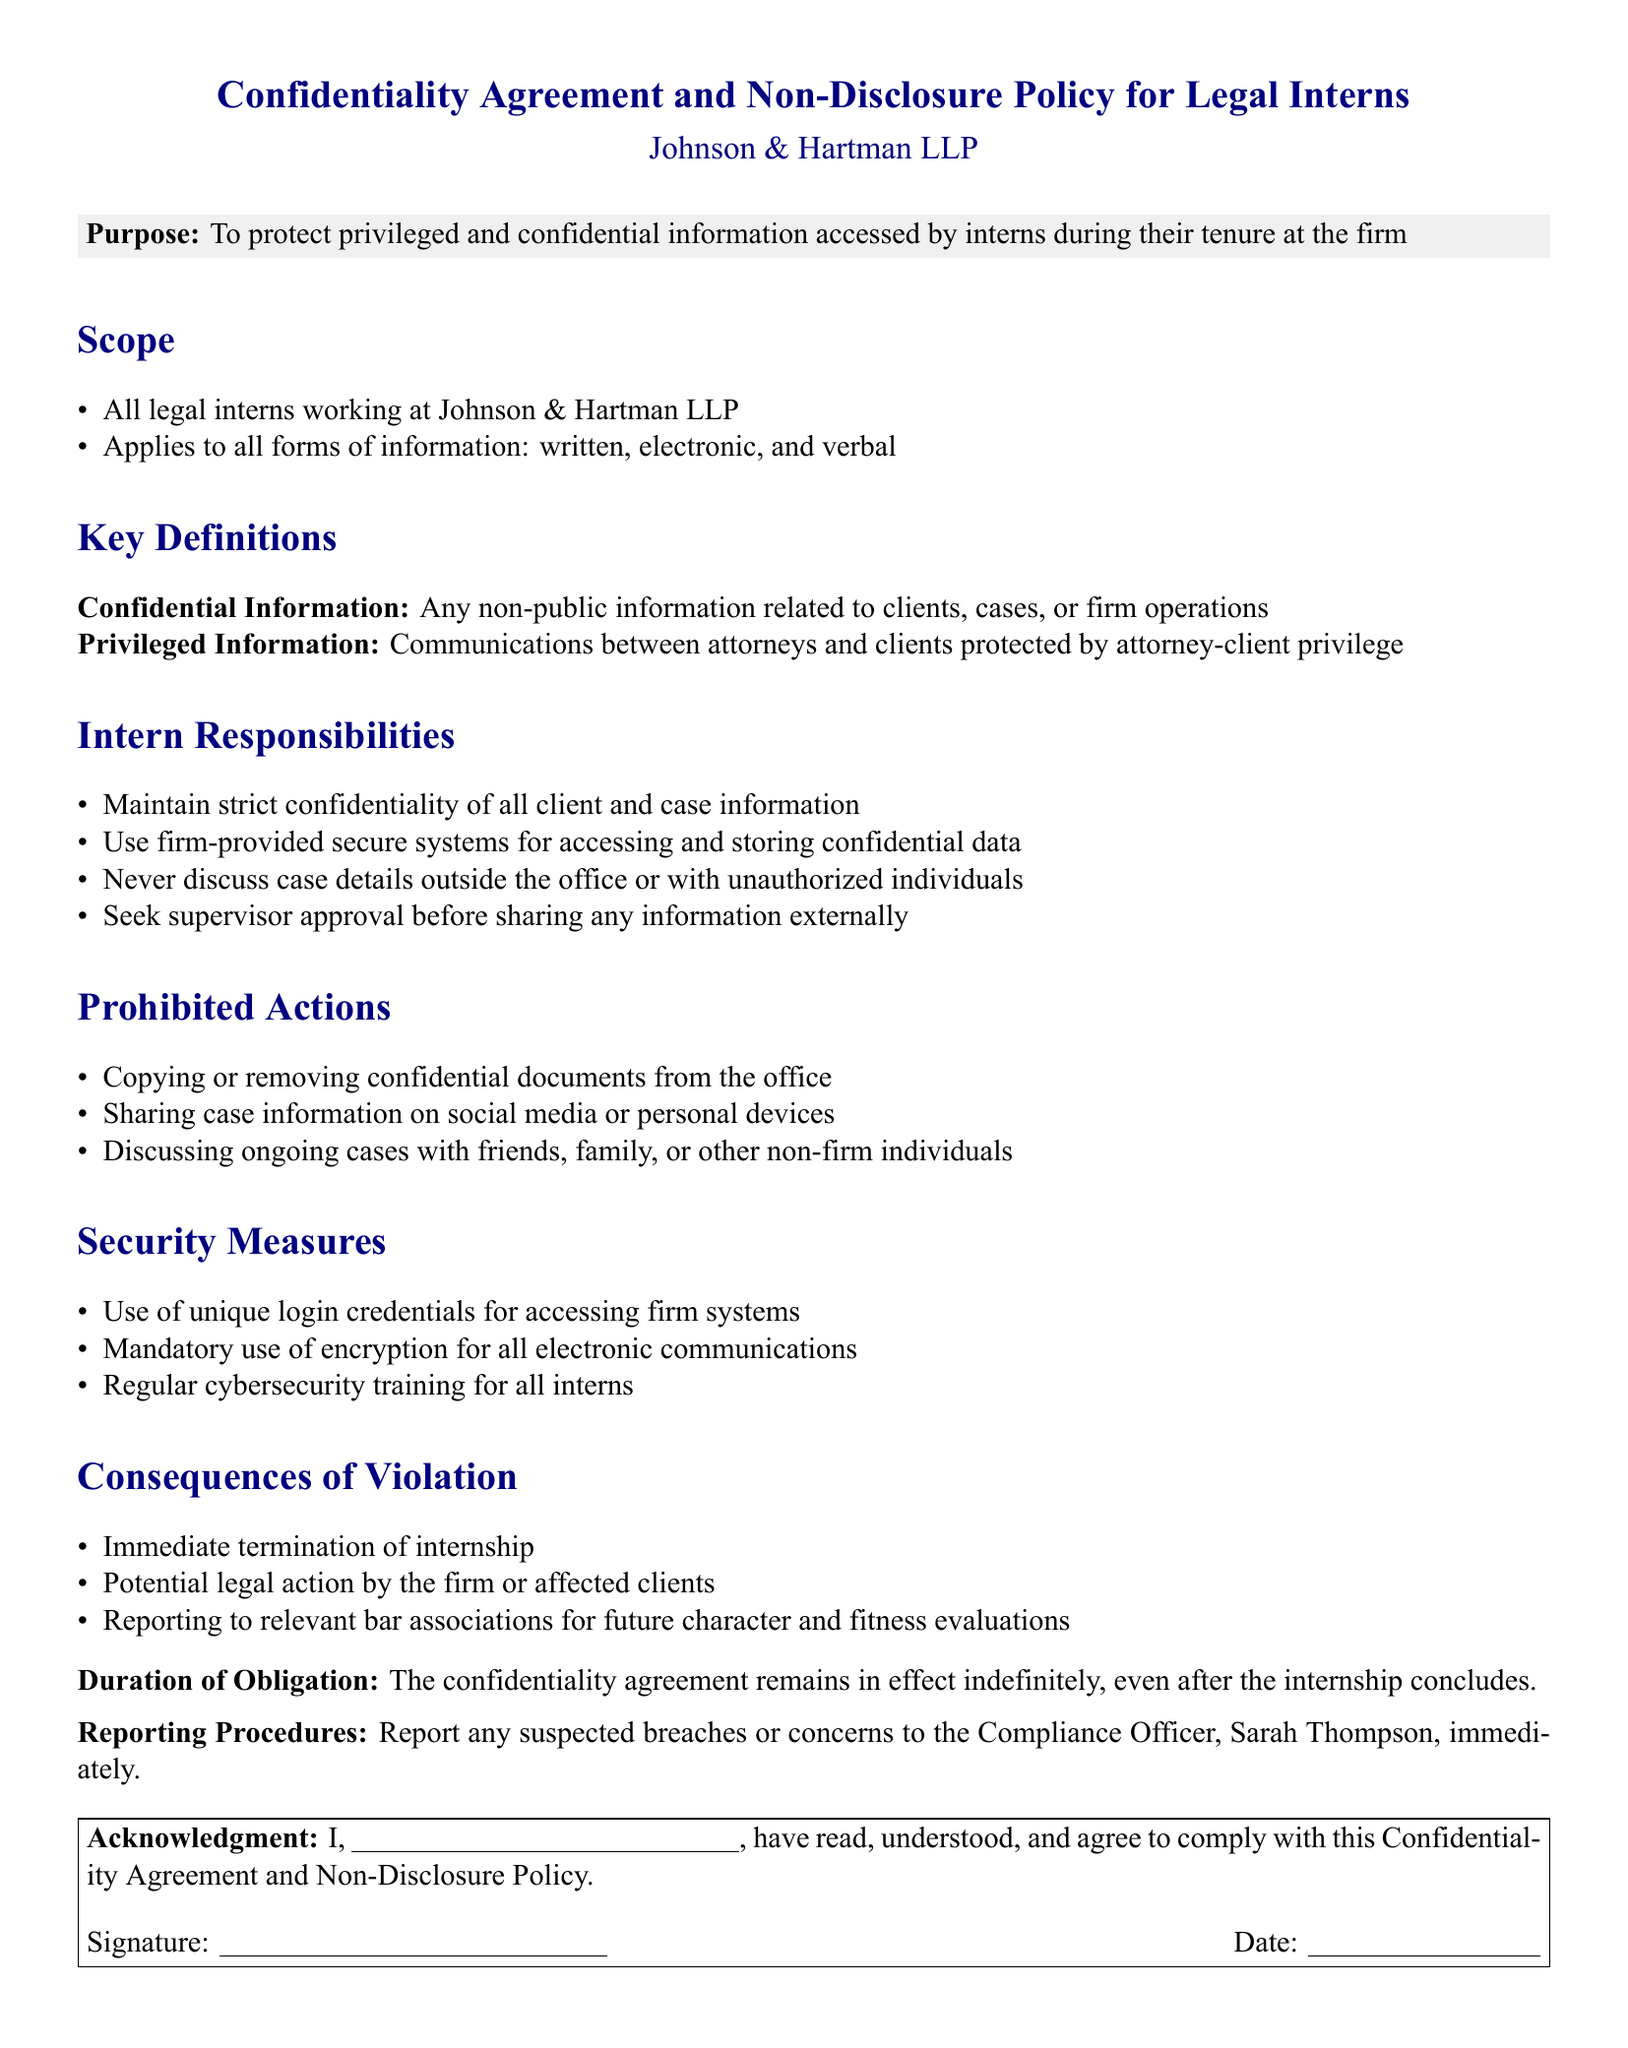What is the purpose of the document? The document outlines the purpose of protecting privileged and confidential information accessed by interns during their tenure at the firm.
Answer: To protect privileged and confidential information Who does the confidentiality agreement apply to? The agreement applies to all interns working at Johnson & Hartman LLP.
Answer: All legal interns What types of information are included in the scope? The document specifies that the confidentiality agreement applies to written, electronic, and verbal information.
Answer: All forms of information What is defined as Privileged Information? The document describes privileged information as communications between attorneys and clients protected by attorney-client privilege.
Answer: Communications between attorneys and clients Name one responsibility of the interns. Intern responsibilities include maintaining strict confidentiality of all client and case information.
Answer: Maintain strict confidentiality What is a prohibited action regarding confidential documents? One prohibited action is copying or removing confidential documents from the office.
Answer: Copying or removing confidential documents What is one security measure mentioned in the document? The document mentions the use of unique login credentials for accessing firm systems as a security measure.
Answer: Unique login credentials What are the consequences of violating the confidentiality agreement? The consequences include immediate termination of internship.
Answer: Immediate termination of internship Who should be contacted in case of suspected breaches? The compliance officer, Sarah Thompson, should be contacted for reporting suspected breaches.
Answer: Sarah Thompson 